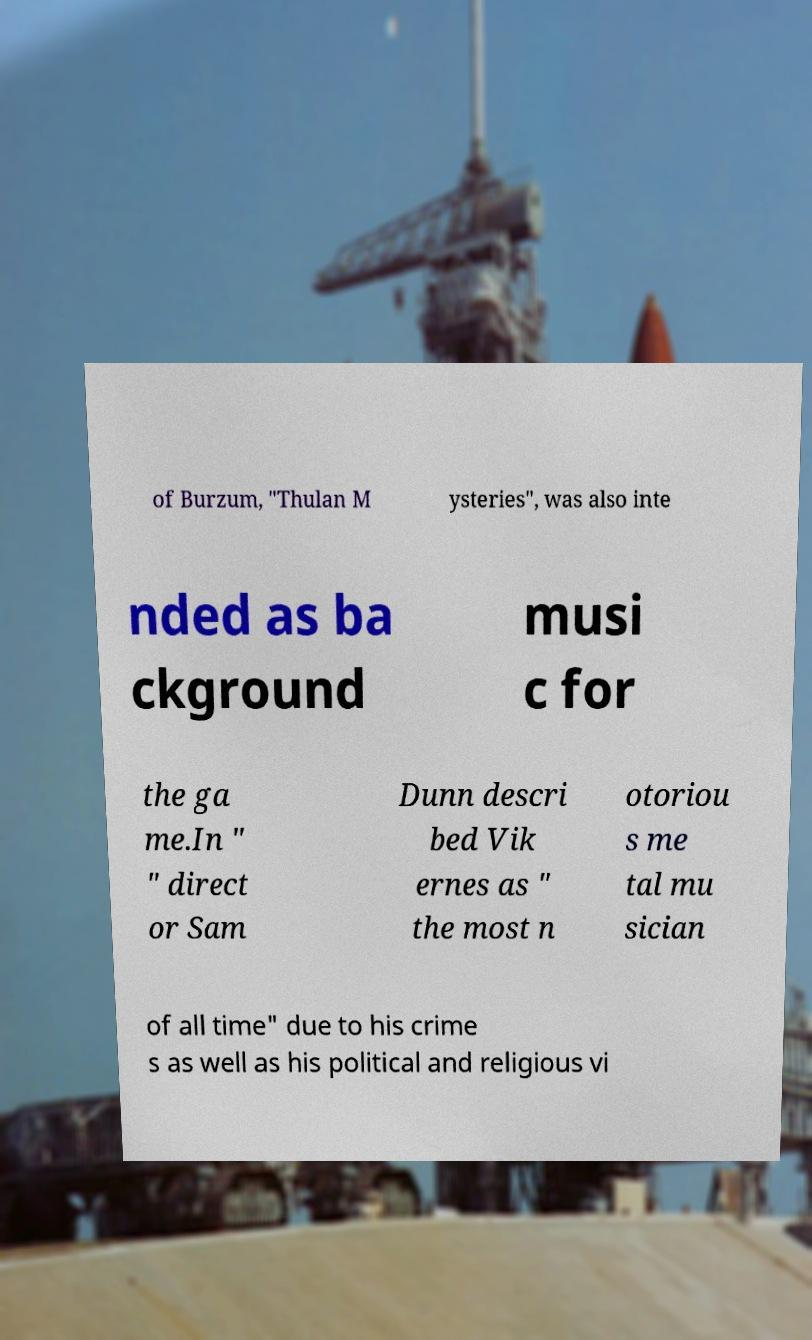What messages or text are displayed in this image? I need them in a readable, typed format. of Burzum, "Thulan M ysteries", was also inte nded as ba ckground musi c for the ga me.In " " direct or Sam Dunn descri bed Vik ernes as " the most n otoriou s me tal mu sician of all time" due to his crime s as well as his political and religious vi 